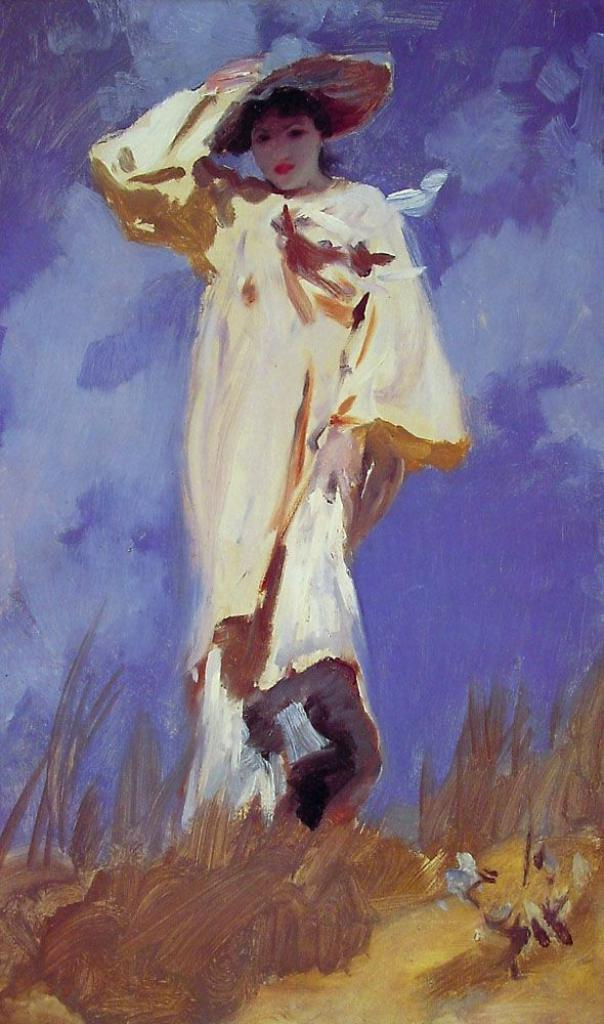What is depicted in the image? The image contains a painting of a woman. Can you describe the woman's attire in the painting? The woman in the painting is wearing a hat. What can be seen in the background of the painting? There is sky visible at the top of the image. What type of bat is flying in the painting? There is no bat present in the painting; it features a woman wearing a hat with sky visible in the background. 